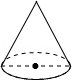Could you explain how one would calculate the area of this cone's base? To calculate the area of the cone's base, which is circular, you would use the formula for the area of a circle: A = πr². Here, 'r' represents the radius of the circle. If the radius is known or can be estimated from the scale provided on the image, you can compute the area. 